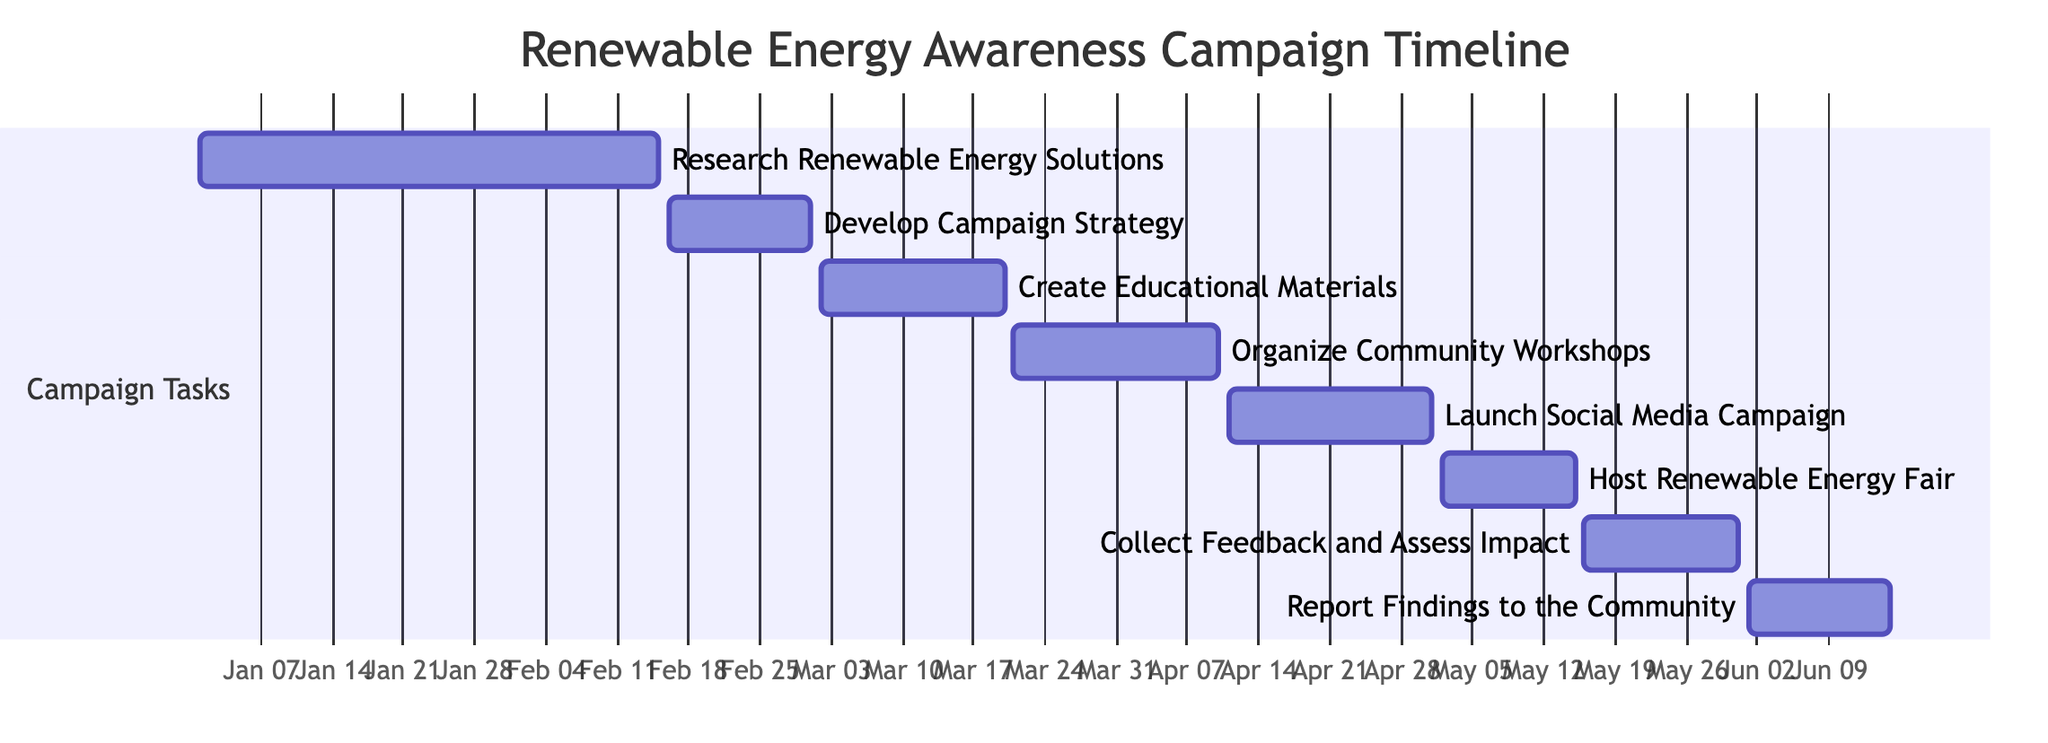What is the duration of the "Research Renewable Energy Solutions" task? The "Research Renewable Energy Solutions" task starts on January 1, 2024, and ends on February 15, 2024. The duration is from the start date to the end date, which is a total of 46 days.
Answer: 46 days How many tasks are in the campaign timeline? The Gantt chart lists a total of 8 tasks, each representing a different stage in the renewable energy awareness campaign.
Answer: 8 tasks Which task occurs immediately after "Organize Community Workshops"? The task that follows "Organize Community Workshops" is "Launch Social Media Campaign." This can be determined by identifying the sequence of tasks shown in the Gantt chart.
Answer: Launch Social Media Campaign What is the start date of the "Host Renewable Energy Fair"? The "Host Renewable Energy Fair" task starts on May 2, 2024, as indicated in the timeline where this task is marked.
Answer: May 2, 2024 Which two tasks overlap in the timeline? The tasks "Launch Social Media Campaign" and "Host Renewable Energy Fair" overlap in the timeline since the former ends on May 1, 2024, and the latter starts on May 2, 2024, showing a back-to-back execution.
Answer: Launch Social Media Campaign and Host Renewable Energy Fair What is the total time span from the start of the campaign to the reporting of findings? The campaign starts on January 1, 2024, and ends with the reporting of findings on June 15, 2024. The total time span can be calculated from the first day to the last day, which is a total of 166 days.
Answer: 166 days Which task has the longest duration? Upon reviewing the durations of each task, "Organize Community Workshops" which lasts from March 21 to April 10, 2024, covering a span of 20 days emerges as one of the longest. However, the "Research Renewable Energy Solutions" task is longer at 46 days.
Answer: Research Renewable Energy Solutions What is the end date for "Collect Feedback and Assess Impact"? The task "Collect Feedback and Assess Impact" ends on May 31, 2024, which is directly indicated in the Gantt chart.
Answer: May 31, 2024 